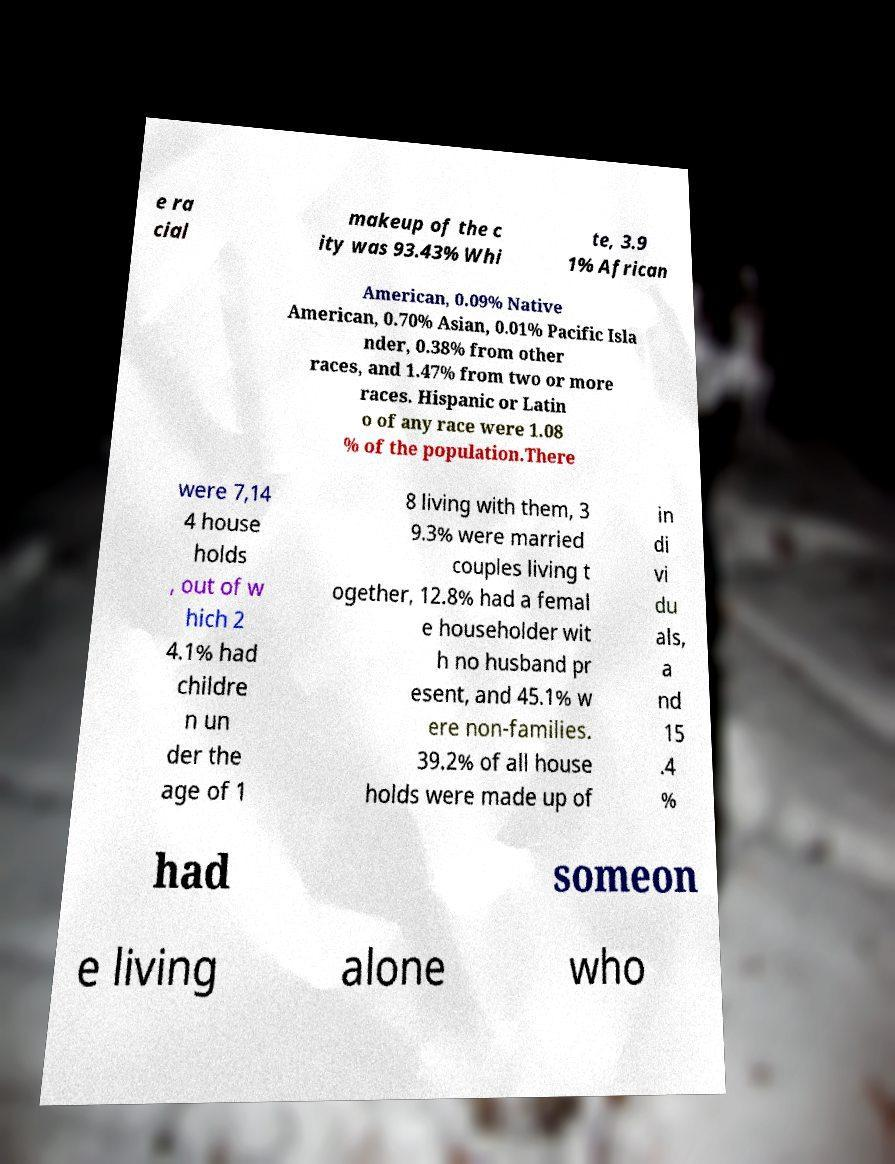Could you assist in decoding the text presented in this image and type it out clearly? e ra cial makeup of the c ity was 93.43% Whi te, 3.9 1% African American, 0.09% Native American, 0.70% Asian, 0.01% Pacific Isla nder, 0.38% from other races, and 1.47% from two or more races. Hispanic or Latin o of any race were 1.08 % of the population.There were 7,14 4 house holds , out of w hich 2 4.1% had childre n un der the age of 1 8 living with them, 3 9.3% were married couples living t ogether, 12.8% had a femal e householder wit h no husband pr esent, and 45.1% w ere non-families. 39.2% of all house holds were made up of in di vi du als, a nd 15 .4 % had someon e living alone who 